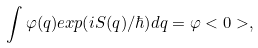Convert formula to latex. <formula><loc_0><loc_0><loc_500><loc_500>\int \varphi ( q ) e x p ( i S ( q ) / \hbar { ) } d q = \varphi < 0 > ,</formula> 